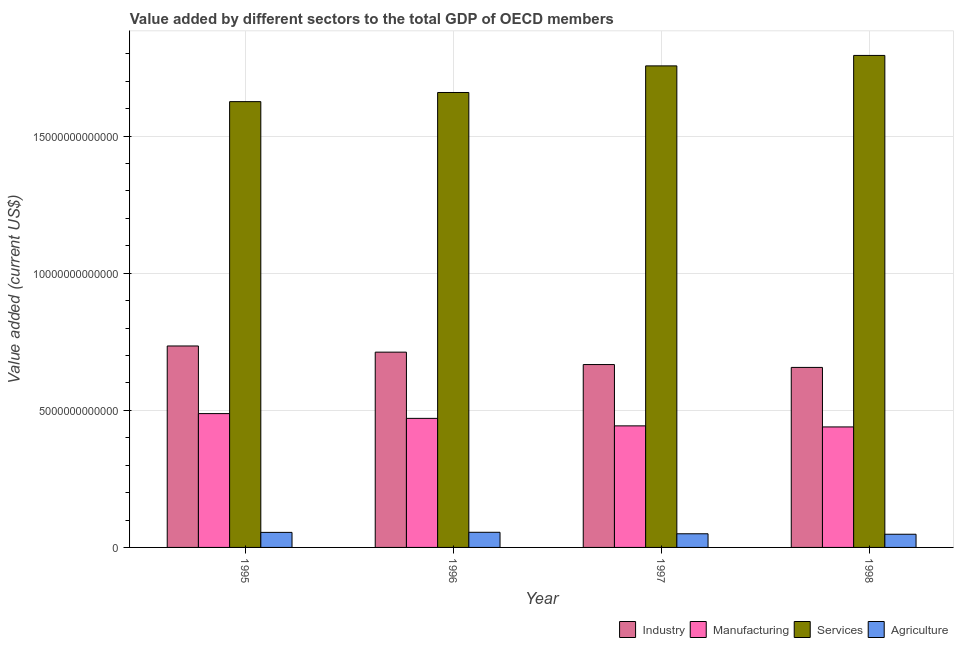How many groups of bars are there?
Your answer should be very brief. 4. Are the number of bars per tick equal to the number of legend labels?
Ensure brevity in your answer.  Yes. How many bars are there on the 3rd tick from the right?
Your answer should be compact. 4. What is the value added by agricultural sector in 1996?
Give a very brief answer. 5.52e+11. Across all years, what is the maximum value added by manufacturing sector?
Your response must be concise. 4.88e+12. Across all years, what is the minimum value added by agricultural sector?
Offer a very short reply. 4.81e+11. In which year was the value added by agricultural sector minimum?
Keep it short and to the point. 1998. What is the total value added by services sector in the graph?
Offer a terse response. 6.84e+13. What is the difference between the value added by industrial sector in 1996 and that in 1997?
Offer a terse response. 4.53e+11. What is the difference between the value added by services sector in 1995 and the value added by manufacturing sector in 1998?
Ensure brevity in your answer.  -1.69e+12. What is the average value added by industrial sector per year?
Offer a terse response. 6.93e+12. What is the ratio of the value added by services sector in 1996 to that in 1997?
Your answer should be compact. 0.94. What is the difference between the highest and the second highest value added by industrial sector?
Your answer should be very brief. 2.25e+11. What is the difference between the highest and the lowest value added by manufacturing sector?
Your answer should be very brief. 4.86e+11. Is it the case that in every year, the sum of the value added by manufacturing sector and value added by services sector is greater than the sum of value added by industrial sector and value added by agricultural sector?
Ensure brevity in your answer.  No. What does the 4th bar from the left in 1997 represents?
Your answer should be very brief. Agriculture. What does the 1st bar from the right in 1997 represents?
Ensure brevity in your answer.  Agriculture. Is it the case that in every year, the sum of the value added by industrial sector and value added by manufacturing sector is greater than the value added by services sector?
Keep it short and to the point. No. How many bars are there?
Provide a short and direct response. 16. Are all the bars in the graph horizontal?
Your answer should be compact. No. How many years are there in the graph?
Provide a short and direct response. 4. What is the difference between two consecutive major ticks on the Y-axis?
Your answer should be very brief. 5.00e+12. Are the values on the major ticks of Y-axis written in scientific E-notation?
Keep it short and to the point. No. Where does the legend appear in the graph?
Your response must be concise. Bottom right. What is the title of the graph?
Your answer should be compact. Value added by different sectors to the total GDP of OECD members. What is the label or title of the Y-axis?
Your response must be concise. Value added (current US$). What is the Value added (current US$) in Industry in 1995?
Keep it short and to the point. 7.35e+12. What is the Value added (current US$) in Manufacturing in 1995?
Ensure brevity in your answer.  4.88e+12. What is the Value added (current US$) in Services in 1995?
Your answer should be very brief. 1.63e+13. What is the Value added (current US$) in Agriculture in 1995?
Provide a succinct answer. 5.49e+11. What is the Value added (current US$) of Industry in 1996?
Your answer should be very brief. 7.12e+12. What is the Value added (current US$) in Manufacturing in 1996?
Offer a very short reply. 4.71e+12. What is the Value added (current US$) of Services in 1996?
Keep it short and to the point. 1.66e+13. What is the Value added (current US$) in Agriculture in 1996?
Provide a short and direct response. 5.52e+11. What is the Value added (current US$) in Industry in 1997?
Offer a terse response. 6.67e+12. What is the Value added (current US$) of Manufacturing in 1997?
Ensure brevity in your answer.  4.43e+12. What is the Value added (current US$) in Services in 1997?
Provide a short and direct response. 1.76e+13. What is the Value added (current US$) of Agriculture in 1997?
Ensure brevity in your answer.  4.98e+11. What is the Value added (current US$) in Industry in 1998?
Offer a terse response. 6.57e+12. What is the Value added (current US$) of Manufacturing in 1998?
Make the answer very short. 4.39e+12. What is the Value added (current US$) in Services in 1998?
Provide a succinct answer. 1.79e+13. What is the Value added (current US$) of Agriculture in 1998?
Ensure brevity in your answer.  4.81e+11. Across all years, what is the maximum Value added (current US$) of Industry?
Keep it short and to the point. 7.35e+12. Across all years, what is the maximum Value added (current US$) of Manufacturing?
Offer a terse response. 4.88e+12. Across all years, what is the maximum Value added (current US$) in Services?
Offer a very short reply. 1.79e+13. Across all years, what is the maximum Value added (current US$) in Agriculture?
Your answer should be compact. 5.52e+11. Across all years, what is the minimum Value added (current US$) of Industry?
Give a very brief answer. 6.57e+12. Across all years, what is the minimum Value added (current US$) of Manufacturing?
Keep it short and to the point. 4.39e+12. Across all years, what is the minimum Value added (current US$) of Services?
Provide a short and direct response. 1.63e+13. Across all years, what is the minimum Value added (current US$) in Agriculture?
Make the answer very short. 4.81e+11. What is the total Value added (current US$) in Industry in the graph?
Make the answer very short. 2.77e+13. What is the total Value added (current US$) in Manufacturing in the graph?
Offer a very short reply. 1.84e+13. What is the total Value added (current US$) in Services in the graph?
Provide a succinct answer. 6.84e+13. What is the total Value added (current US$) in Agriculture in the graph?
Offer a terse response. 2.08e+12. What is the difference between the Value added (current US$) in Industry in 1995 and that in 1996?
Make the answer very short. 2.25e+11. What is the difference between the Value added (current US$) of Manufacturing in 1995 and that in 1996?
Give a very brief answer. 1.74e+11. What is the difference between the Value added (current US$) in Services in 1995 and that in 1996?
Offer a very short reply. -3.33e+11. What is the difference between the Value added (current US$) of Agriculture in 1995 and that in 1996?
Your response must be concise. -3.28e+09. What is the difference between the Value added (current US$) of Industry in 1995 and that in 1997?
Your answer should be very brief. 6.78e+11. What is the difference between the Value added (current US$) of Manufacturing in 1995 and that in 1997?
Ensure brevity in your answer.  4.47e+11. What is the difference between the Value added (current US$) in Services in 1995 and that in 1997?
Your response must be concise. -1.30e+12. What is the difference between the Value added (current US$) in Agriculture in 1995 and that in 1997?
Give a very brief answer. 5.10e+1. What is the difference between the Value added (current US$) in Industry in 1995 and that in 1998?
Ensure brevity in your answer.  7.82e+11. What is the difference between the Value added (current US$) in Manufacturing in 1995 and that in 1998?
Your response must be concise. 4.86e+11. What is the difference between the Value added (current US$) of Services in 1995 and that in 1998?
Your response must be concise. -1.69e+12. What is the difference between the Value added (current US$) of Agriculture in 1995 and that in 1998?
Give a very brief answer. 6.80e+1. What is the difference between the Value added (current US$) of Industry in 1996 and that in 1997?
Offer a very short reply. 4.53e+11. What is the difference between the Value added (current US$) in Manufacturing in 1996 and that in 1997?
Offer a very short reply. 2.73e+11. What is the difference between the Value added (current US$) of Services in 1996 and that in 1997?
Keep it short and to the point. -9.71e+11. What is the difference between the Value added (current US$) of Agriculture in 1996 and that in 1997?
Make the answer very short. 5.43e+1. What is the difference between the Value added (current US$) in Industry in 1996 and that in 1998?
Provide a succinct answer. 5.57e+11. What is the difference between the Value added (current US$) of Manufacturing in 1996 and that in 1998?
Your answer should be compact. 3.12e+11. What is the difference between the Value added (current US$) in Services in 1996 and that in 1998?
Ensure brevity in your answer.  -1.35e+12. What is the difference between the Value added (current US$) of Agriculture in 1996 and that in 1998?
Provide a succinct answer. 7.13e+1. What is the difference between the Value added (current US$) in Industry in 1997 and that in 1998?
Your answer should be very brief. 1.04e+11. What is the difference between the Value added (current US$) of Manufacturing in 1997 and that in 1998?
Offer a terse response. 3.89e+1. What is the difference between the Value added (current US$) in Services in 1997 and that in 1998?
Offer a terse response. -3.81e+11. What is the difference between the Value added (current US$) of Agriculture in 1997 and that in 1998?
Your response must be concise. 1.70e+1. What is the difference between the Value added (current US$) of Industry in 1995 and the Value added (current US$) of Manufacturing in 1996?
Give a very brief answer. 2.64e+12. What is the difference between the Value added (current US$) in Industry in 1995 and the Value added (current US$) in Services in 1996?
Offer a very short reply. -9.24e+12. What is the difference between the Value added (current US$) in Industry in 1995 and the Value added (current US$) in Agriculture in 1996?
Keep it short and to the point. 6.80e+12. What is the difference between the Value added (current US$) in Manufacturing in 1995 and the Value added (current US$) in Services in 1996?
Ensure brevity in your answer.  -1.17e+13. What is the difference between the Value added (current US$) in Manufacturing in 1995 and the Value added (current US$) in Agriculture in 1996?
Provide a short and direct response. 4.33e+12. What is the difference between the Value added (current US$) in Services in 1995 and the Value added (current US$) in Agriculture in 1996?
Offer a very short reply. 1.57e+13. What is the difference between the Value added (current US$) in Industry in 1995 and the Value added (current US$) in Manufacturing in 1997?
Provide a succinct answer. 2.91e+12. What is the difference between the Value added (current US$) in Industry in 1995 and the Value added (current US$) in Services in 1997?
Your answer should be compact. -1.02e+13. What is the difference between the Value added (current US$) of Industry in 1995 and the Value added (current US$) of Agriculture in 1997?
Make the answer very short. 6.85e+12. What is the difference between the Value added (current US$) in Manufacturing in 1995 and the Value added (current US$) in Services in 1997?
Provide a short and direct response. -1.27e+13. What is the difference between the Value added (current US$) in Manufacturing in 1995 and the Value added (current US$) in Agriculture in 1997?
Give a very brief answer. 4.38e+12. What is the difference between the Value added (current US$) of Services in 1995 and the Value added (current US$) of Agriculture in 1997?
Your answer should be compact. 1.58e+13. What is the difference between the Value added (current US$) in Industry in 1995 and the Value added (current US$) in Manufacturing in 1998?
Ensure brevity in your answer.  2.95e+12. What is the difference between the Value added (current US$) in Industry in 1995 and the Value added (current US$) in Services in 1998?
Offer a terse response. -1.06e+13. What is the difference between the Value added (current US$) of Industry in 1995 and the Value added (current US$) of Agriculture in 1998?
Give a very brief answer. 6.87e+12. What is the difference between the Value added (current US$) in Manufacturing in 1995 and the Value added (current US$) in Services in 1998?
Ensure brevity in your answer.  -1.31e+13. What is the difference between the Value added (current US$) in Manufacturing in 1995 and the Value added (current US$) in Agriculture in 1998?
Provide a short and direct response. 4.40e+12. What is the difference between the Value added (current US$) of Services in 1995 and the Value added (current US$) of Agriculture in 1998?
Provide a short and direct response. 1.58e+13. What is the difference between the Value added (current US$) in Industry in 1996 and the Value added (current US$) in Manufacturing in 1997?
Offer a terse response. 2.69e+12. What is the difference between the Value added (current US$) in Industry in 1996 and the Value added (current US$) in Services in 1997?
Make the answer very short. -1.04e+13. What is the difference between the Value added (current US$) of Industry in 1996 and the Value added (current US$) of Agriculture in 1997?
Provide a short and direct response. 6.62e+12. What is the difference between the Value added (current US$) of Manufacturing in 1996 and the Value added (current US$) of Services in 1997?
Offer a very short reply. -1.29e+13. What is the difference between the Value added (current US$) of Manufacturing in 1996 and the Value added (current US$) of Agriculture in 1997?
Your answer should be very brief. 4.21e+12. What is the difference between the Value added (current US$) of Services in 1996 and the Value added (current US$) of Agriculture in 1997?
Give a very brief answer. 1.61e+13. What is the difference between the Value added (current US$) of Industry in 1996 and the Value added (current US$) of Manufacturing in 1998?
Offer a terse response. 2.73e+12. What is the difference between the Value added (current US$) in Industry in 1996 and the Value added (current US$) in Services in 1998?
Provide a short and direct response. -1.08e+13. What is the difference between the Value added (current US$) of Industry in 1996 and the Value added (current US$) of Agriculture in 1998?
Provide a short and direct response. 6.64e+12. What is the difference between the Value added (current US$) of Manufacturing in 1996 and the Value added (current US$) of Services in 1998?
Offer a terse response. -1.32e+13. What is the difference between the Value added (current US$) of Manufacturing in 1996 and the Value added (current US$) of Agriculture in 1998?
Ensure brevity in your answer.  4.23e+12. What is the difference between the Value added (current US$) in Services in 1996 and the Value added (current US$) in Agriculture in 1998?
Keep it short and to the point. 1.61e+13. What is the difference between the Value added (current US$) of Industry in 1997 and the Value added (current US$) of Manufacturing in 1998?
Make the answer very short. 2.27e+12. What is the difference between the Value added (current US$) of Industry in 1997 and the Value added (current US$) of Services in 1998?
Offer a very short reply. -1.13e+13. What is the difference between the Value added (current US$) of Industry in 1997 and the Value added (current US$) of Agriculture in 1998?
Provide a short and direct response. 6.19e+12. What is the difference between the Value added (current US$) of Manufacturing in 1997 and the Value added (current US$) of Services in 1998?
Your answer should be compact. -1.35e+13. What is the difference between the Value added (current US$) in Manufacturing in 1997 and the Value added (current US$) in Agriculture in 1998?
Your answer should be very brief. 3.95e+12. What is the difference between the Value added (current US$) in Services in 1997 and the Value added (current US$) in Agriculture in 1998?
Make the answer very short. 1.71e+13. What is the average Value added (current US$) of Industry per year?
Offer a very short reply. 6.93e+12. What is the average Value added (current US$) in Manufacturing per year?
Provide a succinct answer. 4.60e+12. What is the average Value added (current US$) of Services per year?
Your response must be concise. 1.71e+13. What is the average Value added (current US$) of Agriculture per year?
Make the answer very short. 5.20e+11. In the year 1995, what is the difference between the Value added (current US$) of Industry and Value added (current US$) of Manufacturing?
Provide a succinct answer. 2.47e+12. In the year 1995, what is the difference between the Value added (current US$) in Industry and Value added (current US$) in Services?
Your response must be concise. -8.91e+12. In the year 1995, what is the difference between the Value added (current US$) in Industry and Value added (current US$) in Agriculture?
Provide a succinct answer. 6.80e+12. In the year 1995, what is the difference between the Value added (current US$) in Manufacturing and Value added (current US$) in Services?
Give a very brief answer. -1.14e+13. In the year 1995, what is the difference between the Value added (current US$) in Manufacturing and Value added (current US$) in Agriculture?
Your response must be concise. 4.33e+12. In the year 1995, what is the difference between the Value added (current US$) of Services and Value added (current US$) of Agriculture?
Provide a short and direct response. 1.57e+13. In the year 1996, what is the difference between the Value added (current US$) in Industry and Value added (current US$) in Manufacturing?
Your response must be concise. 2.42e+12. In the year 1996, what is the difference between the Value added (current US$) of Industry and Value added (current US$) of Services?
Make the answer very short. -9.47e+12. In the year 1996, what is the difference between the Value added (current US$) of Industry and Value added (current US$) of Agriculture?
Your answer should be very brief. 6.57e+12. In the year 1996, what is the difference between the Value added (current US$) of Manufacturing and Value added (current US$) of Services?
Offer a very short reply. -1.19e+13. In the year 1996, what is the difference between the Value added (current US$) of Manufacturing and Value added (current US$) of Agriculture?
Your answer should be very brief. 4.15e+12. In the year 1996, what is the difference between the Value added (current US$) in Services and Value added (current US$) in Agriculture?
Make the answer very short. 1.60e+13. In the year 1997, what is the difference between the Value added (current US$) in Industry and Value added (current US$) in Manufacturing?
Your answer should be compact. 2.24e+12. In the year 1997, what is the difference between the Value added (current US$) in Industry and Value added (current US$) in Services?
Make the answer very short. -1.09e+13. In the year 1997, what is the difference between the Value added (current US$) in Industry and Value added (current US$) in Agriculture?
Your response must be concise. 6.17e+12. In the year 1997, what is the difference between the Value added (current US$) in Manufacturing and Value added (current US$) in Services?
Provide a short and direct response. -1.31e+13. In the year 1997, what is the difference between the Value added (current US$) in Manufacturing and Value added (current US$) in Agriculture?
Offer a terse response. 3.94e+12. In the year 1997, what is the difference between the Value added (current US$) in Services and Value added (current US$) in Agriculture?
Keep it short and to the point. 1.71e+13. In the year 1998, what is the difference between the Value added (current US$) in Industry and Value added (current US$) in Manufacturing?
Offer a very short reply. 2.17e+12. In the year 1998, what is the difference between the Value added (current US$) in Industry and Value added (current US$) in Services?
Keep it short and to the point. -1.14e+13. In the year 1998, what is the difference between the Value added (current US$) in Industry and Value added (current US$) in Agriculture?
Ensure brevity in your answer.  6.08e+12. In the year 1998, what is the difference between the Value added (current US$) in Manufacturing and Value added (current US$) in Services?
Give a very brief answer. -1.35e+13. In the year 1998, what is the difference between the Value added (current US$) of Manufacturing and Value added (current US$) of Agriculture?
Ensure brevity in your answer.  3.91e+12. In the year 1998, what is the difference between the Value added (current US$) of Services and Value added (current US$) of Agriculture?
Provide a succinct answer. 1.75e+13. What is the ratio of the Value added (current US$) of Industry in 1995 to that in 1996?
Ensure brevity in your answer.  1.03. What is the ratio of the Value added (current US$) of Manufacturing in 1995 to that in 1996?
Provide a short and direct response. 1.04. What is the ratio of the Value added (current US$) of Services in 1995 to that in 1996?
Your answer should be compact. 0.98. What is the ratio of the Value added (current US$) in Industry in 1995 to that in 1997?
Your answer should be very brief. 1.1. What is the ratio of the Value added (current US$) in Manufacturing in 1995 to that in 1997?
Your answer should be compact. 1.1. What is the ratio of the Value added (current US$) in Services in 1995 to that in 1997?
Provide a succinct answer. 0.93. What is the ratio of the Value added (current US$) in Agriculture in 1995 to that in 1997?
Provide a succinct answer. 1.1. What is the ratio of the Value added (current US$) of Industry in 1995 to that in 1998?
Give a very brief answer. 1.12. What is the ratio of the Value added (current US$) of Manufacturing in 1995 to that in 1998?
Keep it short and to the point. 1.11. What is the ratio of the Value added (current US$) of Services in 1995 to that in 1998?
Your answer should be very brief. 0.91. What is the ratio of the Value added (current US$) of Agriculture in 1995 to that in 1998?
Provide a succinct answer. 1.14. What is the ratio of the Value added (current US$) in Industry in 1996 to that in 1997?
Your answer should be very brief. 1.07. What is the ratio of the Value added (current US$) of Manufacturing in 1996 to that in 1997?
Provide a succinct answer. 1.06. What is the ratio of the Value added (current US$) in Services in 1996 to that in 1997?
Give a very brief answer. 0.94. What is the ratio of the Value added (current US$) in Agriculture in 1996 to that in 1997?
Make the answer very short. 1.11. What is the ratio of the Value added (current US$) in Industry in 1996 to that in 1998?
Offer a terse response. 1.08. What is the ratio of the Value added (current US$) in Manufacturing in 1996 to that in 1998?
Keep it short and to the point. 1.07. What is the ratio of the Value added (current US$) of Services in 1996 to that in 1998?
Provide a succinct answer. 0.92. What is the ratio of the Value added (current US$) in Agriculture in 1996 to that in 1998?
Your answer should be compact. 1.15. What is the ratio of the Value added (current US$) in Industry in 1997 to that in 1998?
Give a very brief answer. 1.02. What is the ratio of the Value added (current US$) in Manufacturing in 1997 to that in 1998?
Make the answer very short. 1.01. What is the ratio of the Value added (current US$) of Services in 1997 to that in 1998?
Offer a very short reply. 0.98. What is the ratio of the Value added (current US$) of Agriculture in 1997 to that in 1998?
Offer a terse response. 1.04. What is the difference between the highest and the second highest Value added (current US$) of Industry?
Make the answer very short. 2.25e+11. What is the difference between the highest and the second highest Value added (current US$) in Manufacturing?
Your answer should be very brief. 1.74e+11. What is the difference between the highest and the second highest Value added (current US$) in Services?
Offer a terse response. 3.81e+11. What is the difference between the highest and the second highest Value added (current US$) in Agriculture?
Ensure brevity in your answer.  3.28e+09. What is the difference between the highest and the lowest Value added (current US$) of Industry?
Your response must be concise. 7.82e+11. What is the difference between the highest and the lowest Value added (current US$) of Manufacturing?
Make the answer very short. 4.86e+11. What is the difference between the highest and the lowest Value added (current US$) of Services?
Offer a terse response. 1.69e+12. What is the difference between the highest and the lowest Value added (current US$) of Agriculture?
Ensure brevity in your answer.  7.13e+1. 